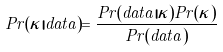Convert formula to latex. <formula><loc_0><loc_0><loc_500><loc_500>P r ( \kappa | d a t a ) = \frac { P r ( d a t a | \kappa ) P r ( \kappa ) } { P r ( d a t a ) }</formula> 